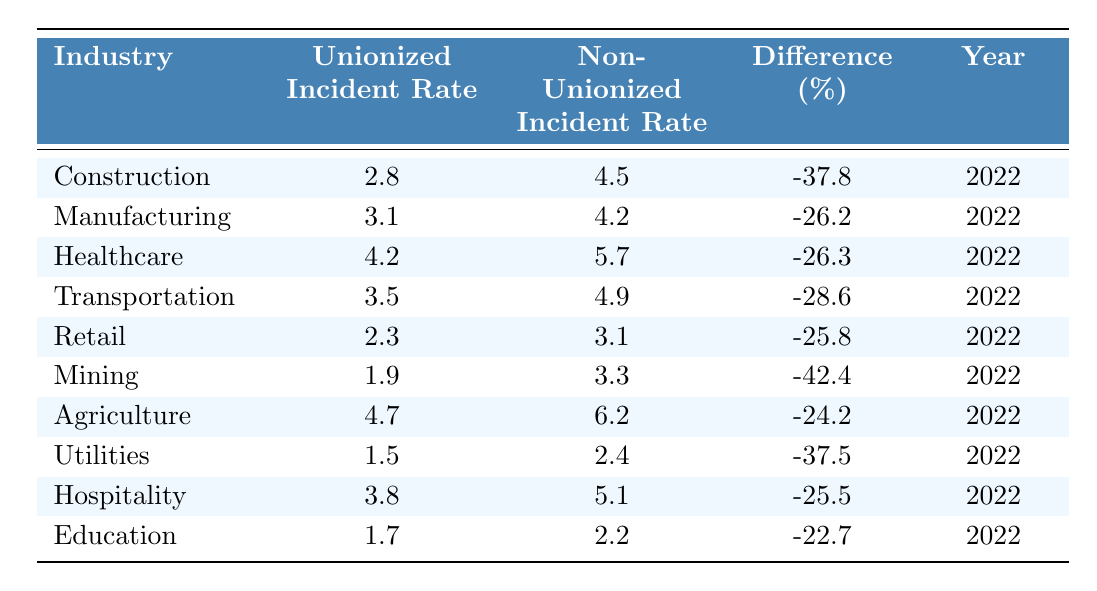What is the Unionized Incident Rate for the Manufacturing industry? According to the table, the Unionized Incident Rate for the Manufacturing industry is directly noted as 3.1 per 100 workers.
Answer: 3.1 What is the Non-Unionized Incident Rate for the Agriculture industry? The Non-Unionized Incident Rate for the Agriculture industry is listed in the table as 6.2 per 100 workers.
Answer: 6.2 Which industry has the lowest Unionized Incident Rate, and what is that rate? By examining the rates in the table, the industry with the lowest Unionized Incident Rate is Utilities, with a rate of 1.5 per 100 workers.
Answer: Utilities, 1.5 Is the statement "Unionized workplaces have higher safety incident rates than non-unionized workplaces" true or false? The table shows that all Unionized Incident Rates are lower than their Non-Unionized counterparts, indicating this statement is false.
Answer: False What is the percentage difference in incident rates for the Mining industry? The Mining industry shows a percentage difference of -42.4%. This indicates a 42.4% reduction in the incident rate of unionized workplaces compared to non-unionized workplaces.
Answer: -42.4% Which industry has the highest difference percentage between unionized and non-unionized incident rates? By evaluating the difference percentages listed, Mining has the highest difference at -42.4%, meaning it has the most significant decline in incident rates for unionized workplaces compared to non-unionized.
Answer: Mining, -42.4% What is the average Unionized Incident Rate across all listed industries? To find the average, sum the Unionized Incident Rates (2.8 + 3.1 + 4.2 + 3.5 + 2.3 + 1.9 + 4.7 + 1.5 + 3.8 + 1.7) which equals 25.7, and then divide by the number of industries (10), resulting in an average of 2.57.
Answer: 2.57 If we focus on the Healthcare and Retail industries, what is the average Non-Unionized Incident Rate? The Non-Unionized Incident Rates for Healthcare and Retail are 5.7 and 3.1 respectively. Adding these gives 8.8, and averaging them (8.8 / 2), we get 4.4 as the average for those two industries.
Answer: 4.4 In how many industries do unionized workplaces have more than a 25% reduction in incident rates compared to non-unionized workplaces? From the table, analyzes the differences: Construction, Manufacturing, Healthcare, Transportation, Retail, Mining, Agriculture, Utilities, Hospitality. All these show more than a 25% reduction, totaling 8 industries.
Answer: 8 What is the incident rate difference for the Hospitality industry, and how does it compare to the Education industry? The Hospitality industry has a difference of -25.5%, while the Education industry has a difference of -22.7%. This means Hospitality has a greater reduction in incident rates compared to Education.
Answer: -25.5% (Hospitality) vs -22.7% (Education) 